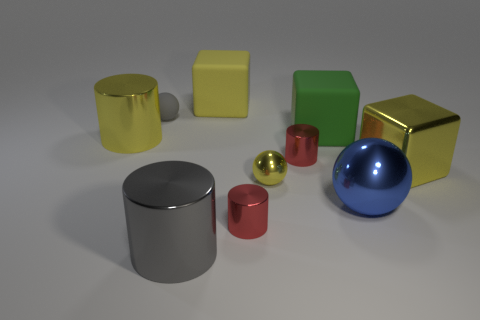Does the gray sphere have the same size as the matte cube to the left of the yellow sphere?
Your answer should be very brief. No. There is a matte object that is both in front of the yellow rubber thing and right of the gray cylinder; what color is it?
Give a very brief answer. Green. What number of other objects are there of the same shape as the large blue object?
Provide a short and direct response. 2. Does the small ball in front of the big green matte thing have the same color as the large rubber cube that is behind the tiny gray rubber object?
Offer a very short reply. Yes. There is a rubber block that is right of the tiny yellow metal ball; does it have the same size as the red metallic cylinder behind the big sphere?
Make the answer very short. No. The small thing to the left of the red shiny cylinder to the left of the cylinder that is on the right side of the tiny yellow shiny object is made of what material?
Your answer should be very brief. Rubber. Is the shape of the small gray object the same as the blue metal object?
Offer a very short reply. Yes. There is a small gray object that is the same shape as the tiny yellow thing; what is it made of?
Your answer should be very brief. Rubber. What number of tiny rubber cylinders have the same color as the small rubber thing?
Provide a succinct answer. 0. What is the size of the blue ball that is made of the same material as the big gray object?
Give a very brief answer. Large. 